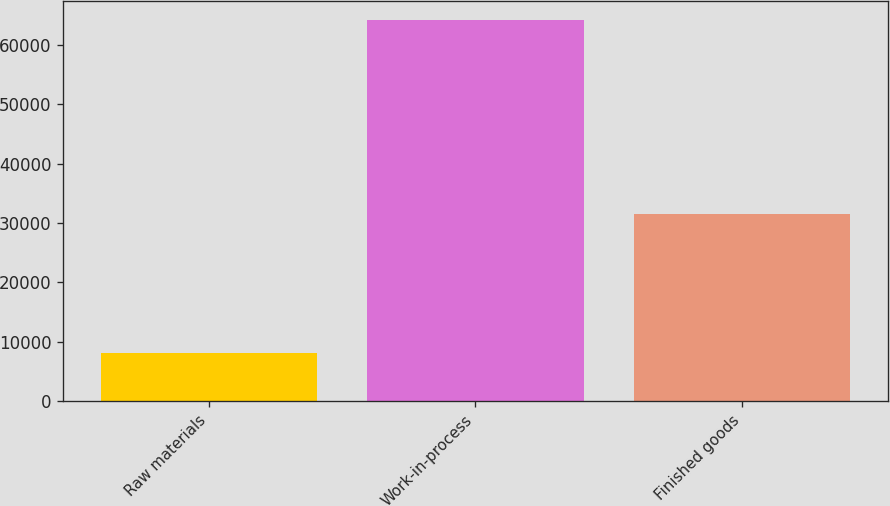Convert chart. <chart><loc_0><loc_0><loc_500><loc_500><bar_chart><fcel>Raw materials<fcel>Work-in-process<fcel>Finished goods<nl><fcel>8005<fcel>64305<fcel>31481<nl></chart> 